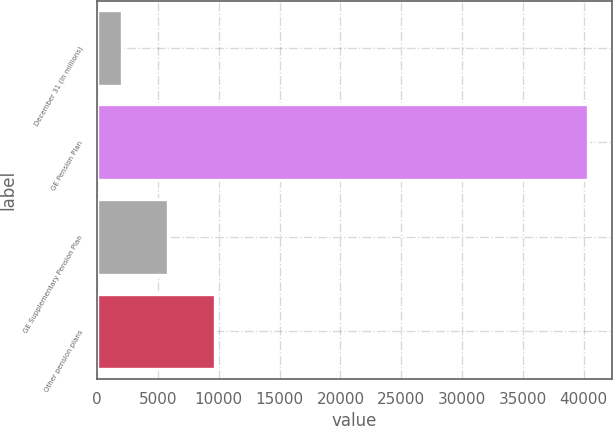<chart> <loc_0><loc_0><loc_500><loc_500><bar_chart><fcel>December 31 (In millions)<fcel>GE Pension Plan<fcel>GE Supplementary Pension Plan<fcel>Other pension plans<nl><fcel>2008<fcel>40313<fcel>5838.5<fcel>9669<nl></chart> 